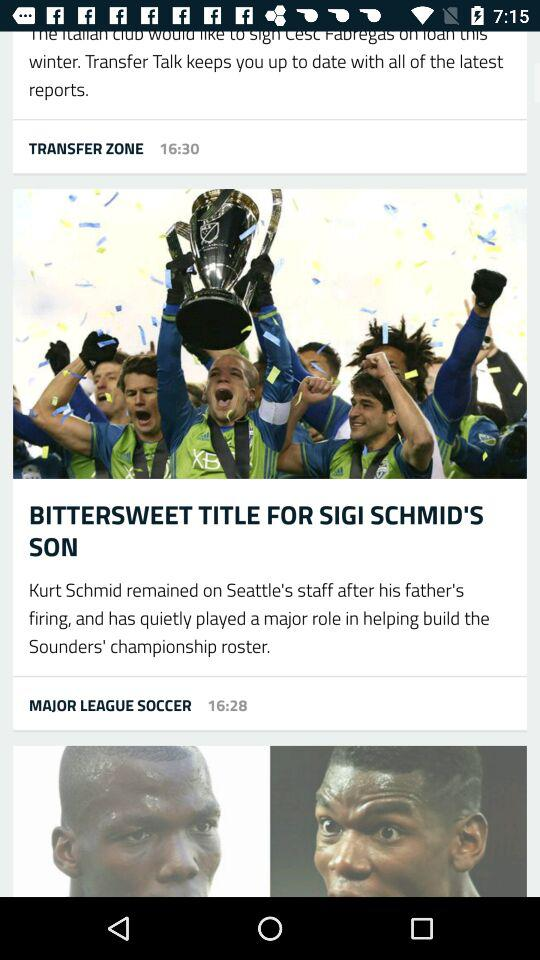What is the posted time of the article given under "TRANSFER ZONE"? The posted time of the article is 16:30. 